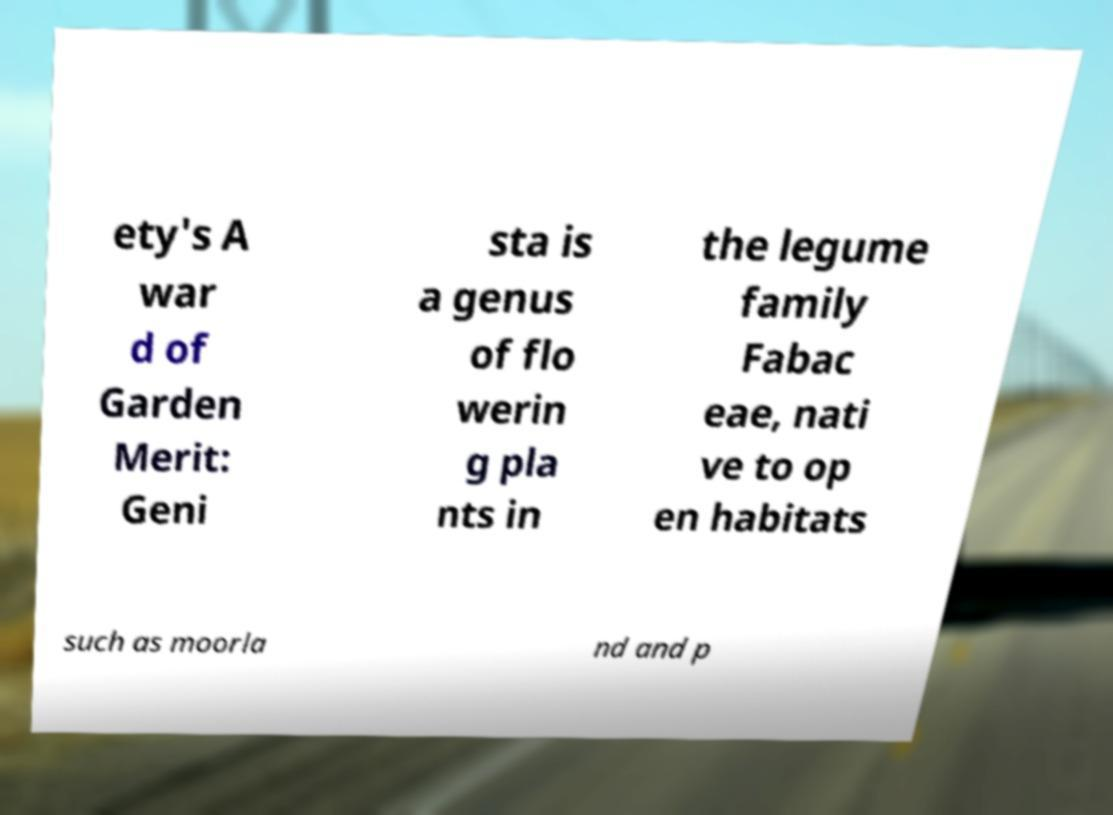There's text embedded in this image that I need extracted. Can you transcribe it verbatim? ety's A war d of Garden Merit: Geni sta is a genus of flo werin g pla nts in the legume family Fabac eae, nati ve to op en habitats such as moorla nd and p 